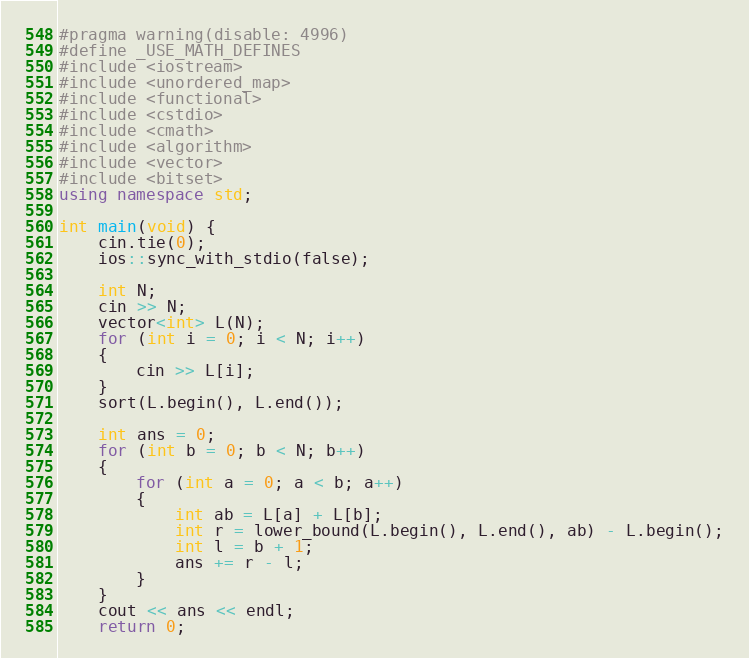Convert code to text. <code><loc_0><loc_0><loc_500><loc_500><_C++_>#pragma warning(disable: 4996)
#define _USE_MATH_DEFINES
#include <iostream>
#include <unordered_map>
#include <functional>
#include <cstdio>
#include <cmath>
#include <algorithm>
#include <vector>
#include <bitset>
using namespace std;

int main(void) {
	cin.tie(0);
	ios::sync_with_stdio(false);

	int N;
	cin >> N;
	vector<int> L(N);
	for (int i = 0; i < N; i++)
	{
		cin >> L[i];
	}
	sort(L.begin(), L.end());

	int ans = 0;
	for (int b = 0; b < N; b++)
	{
		for (int a = 0; a < b; a++)
		{
			int ab = L[a] + L[b];
			int r = lower_bound(L.begin(), L.end(), ab) - L.begin();
			int l = b + 1;
			ans += r - l;
		}
	}
	cout << ans << endl;
	return 0;</code> 